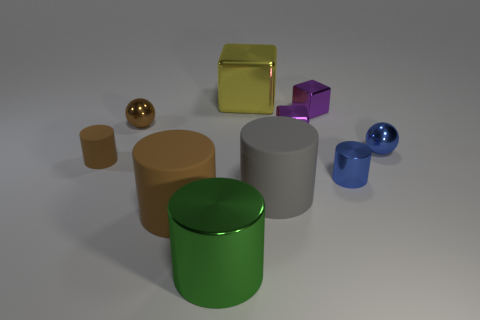Subtract all blue cylinders. How many cylinders are left? 4 Subtract all big green cylinders. How many cylinders are left? 4 Subtract all blue cylinders. Subtract all gray cubes. How many cylinders are left? 4 Subtract all spheres. How many objects are left? 8 Subtract 0 gray spheres. How many objects are left? 10 Subtract all yellow cubes. Subtract all small brown cylinders. How many objects are left? 8 Add 9 gray cylinders. How many gray cylinders are left? 10 Add 9 big cubes. How many big cubes exist? 10 